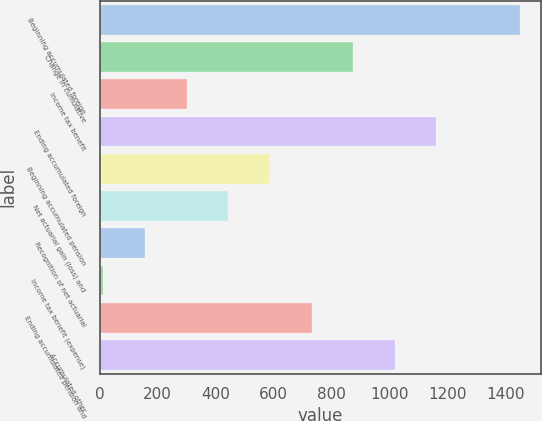Convert chart to OTSL. <chart><loc_0><loc_0><loc_500><loc_500><bar_chart><fcel>Beginning accumulated foreign<fcel>Change in cumulative<fcel>Income tax benefit<fcel>Ending accumulated foreign<fcel>Beginning accumulated pension<fcel>Net actuarial gain (loss) and<fcel>Recognition of net actuarial<fcel>Income tax benefit (expense)<fcel>Ending accumulated pension and<fcel>Accumulated other<nl><fcel>1448<fcel>874<fcel>300<fcel>1161<fcel>587<fcel>443.5<fcel>156.5<fcel>13<fcel>730.5<fcel>1017.5<nl></chart> 